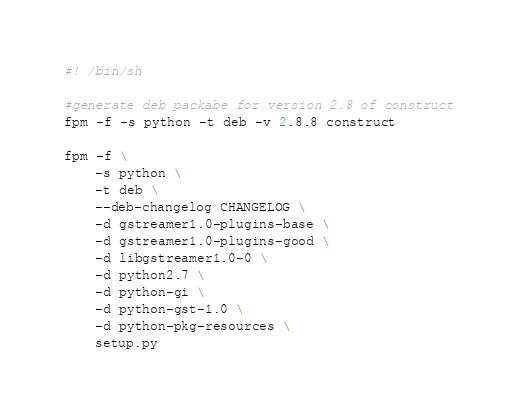<code> <loc_0><loc_0><loc_500><loc_500><_Bash_>#! /bin/sh

#generate deb packabe for version 2.8 of construct
fpm -f -s python -t deb -v 2.8.8 construct

fpm -f \
	-s python \
	-t deb \
	--deb-changelog CHANGELOG \
	-d gstreamer1.0-plugins-base \
	-d gstreamer1.0-plugins-good \
	-d libgstreamer1.0-0 \
	-d python2.7 \
	-d python-gi \
	-d python-gst-1.0 \
	-d python-pkg-resources \
	setup.py
</code> 